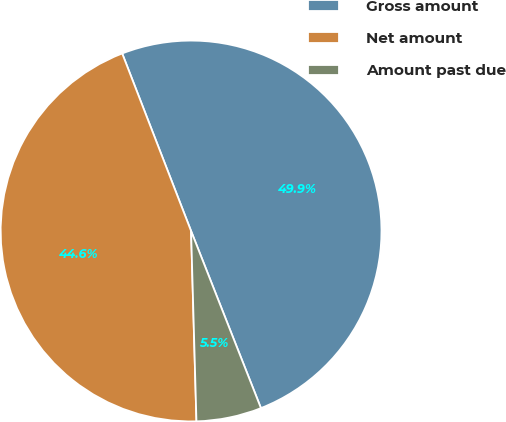Convert chart. <chart><loc_0><loc_0><loc_500><loc_500><pie_chart><fcel>Gross amount<fcel>Net amount<fcel>Amount past due<nl><fcel>49.91%<fcel>44.56%<fcel>5.53%<nl></chart> 